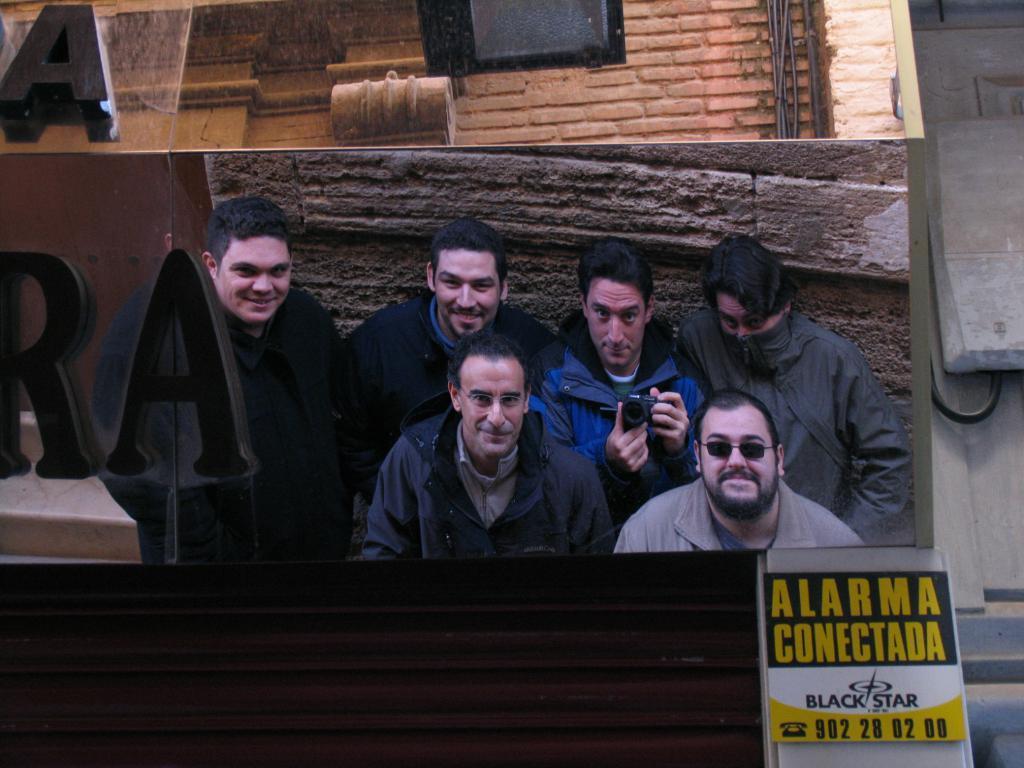Describe this image in one or two sentences. In the center of the image we can see a board. On the board we can see some people are wearing the jackets and a man is holding a camera and another man is wearing goggles. In the background of the image we can see the wall, screen, naming boards, board, stairs, cable. 